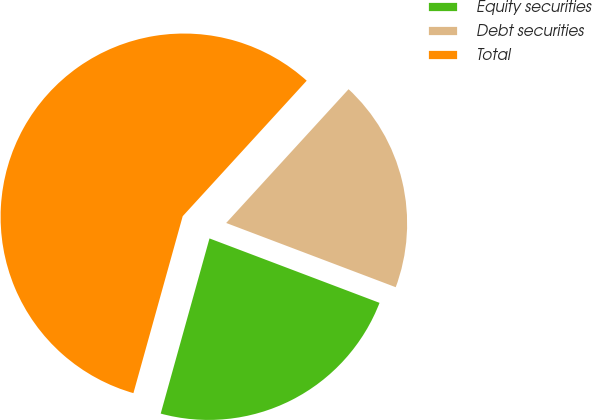Convert chart. <chart><loc_0><loc_0><loc_500><loc_500><pie_chart><fcel>Equity securities<fcel>Debt securities<fcel>Total<nl><fcel>23.56%<fcel>18.97%<fcel>57.47%<nl></chart> 